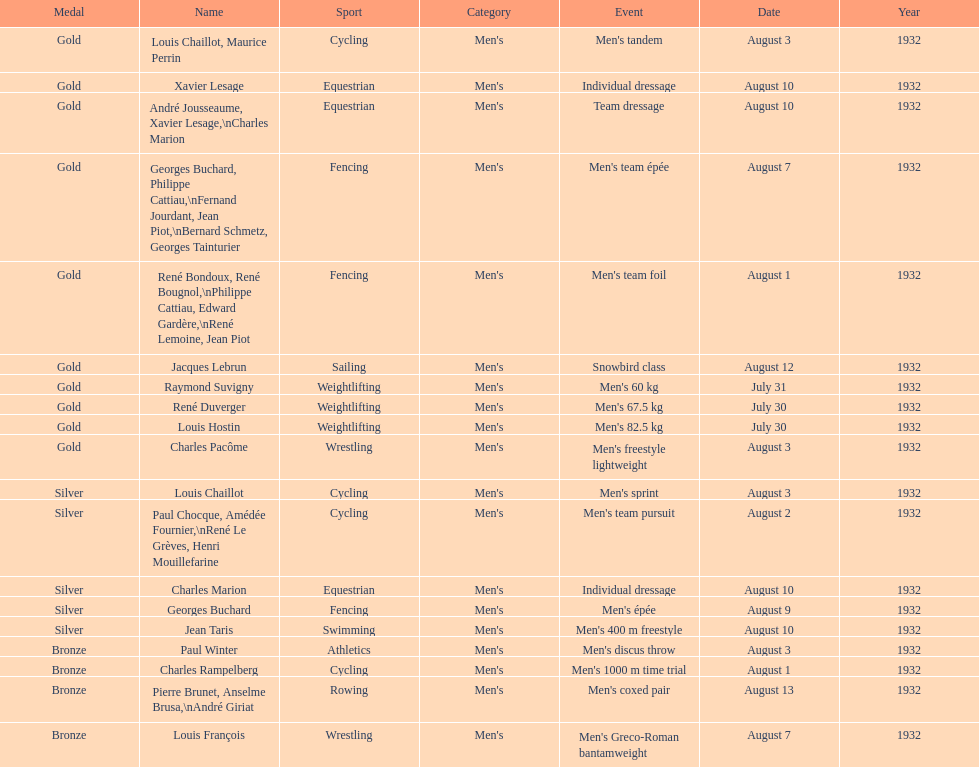Which event won the most medals? Cycling. 